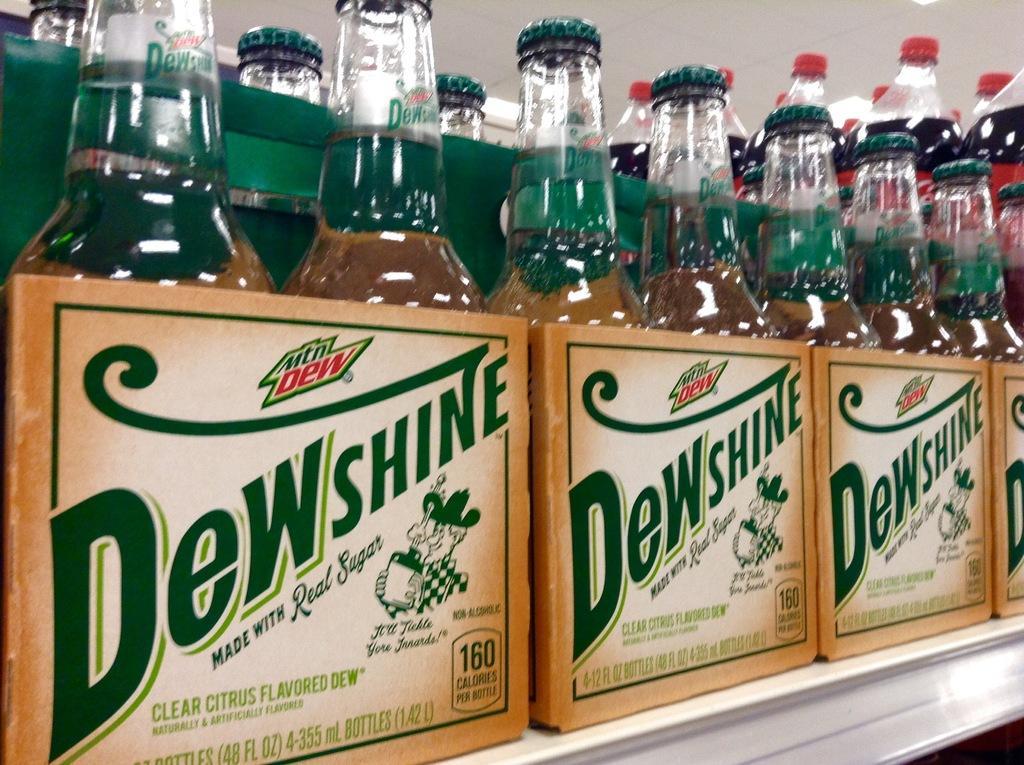Please provide a concise description of this image. Some bottles of cool drinks are placed in a rack. 